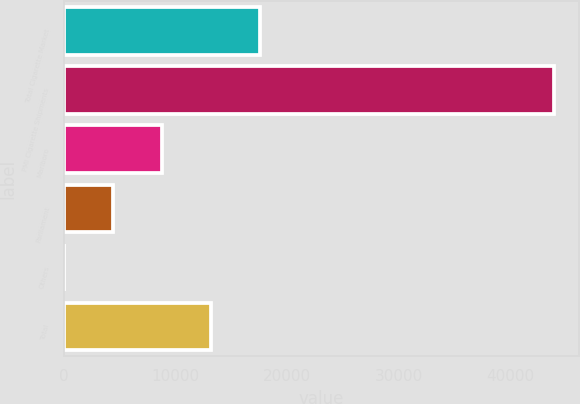Convert chart to OTSL. <chart><loc_0><loc_0><loc_500><loc_500><bar_chart><fcel>Total Cigarette Market<fcel>PMI Cigarette Shipments<fcel>Marlboro<fcel>Parliament<fcel>Others<fcel>Total<nl><fcel>17567<fcel>43915<fcel>8784.36<fcel>4393.03<fcel>1.7<fcel>13175.7<nl></chart> 